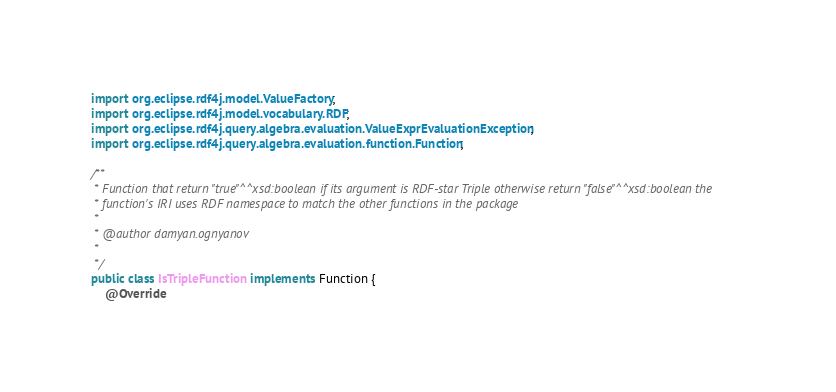<code> <loc_0><loc_0><loc_500><loc_500><_Java_>import org.eclipse.rdf4j.model.ValueFactory;
import org.eclipse.rdf4j.model.vocabulary.RDF;
import org.eclipse.rdf4j.query.algebra.evaluation.ValueExprEvaluationException;
import org.eclipse.rdf4j.query.algebra.evaluation.function.Function;

/**
 * Function that return "true"^^xsd:boolean if its argument is RDF-star Triple otherwise return "false"^^xsd:boolean the
 * function's IRI uses RDF namespace to match the other functions in the package
 *
 * @author damyan.ognyanov
 *
 */
public class IsTripleFunction implements Function {
	@Override</code> 